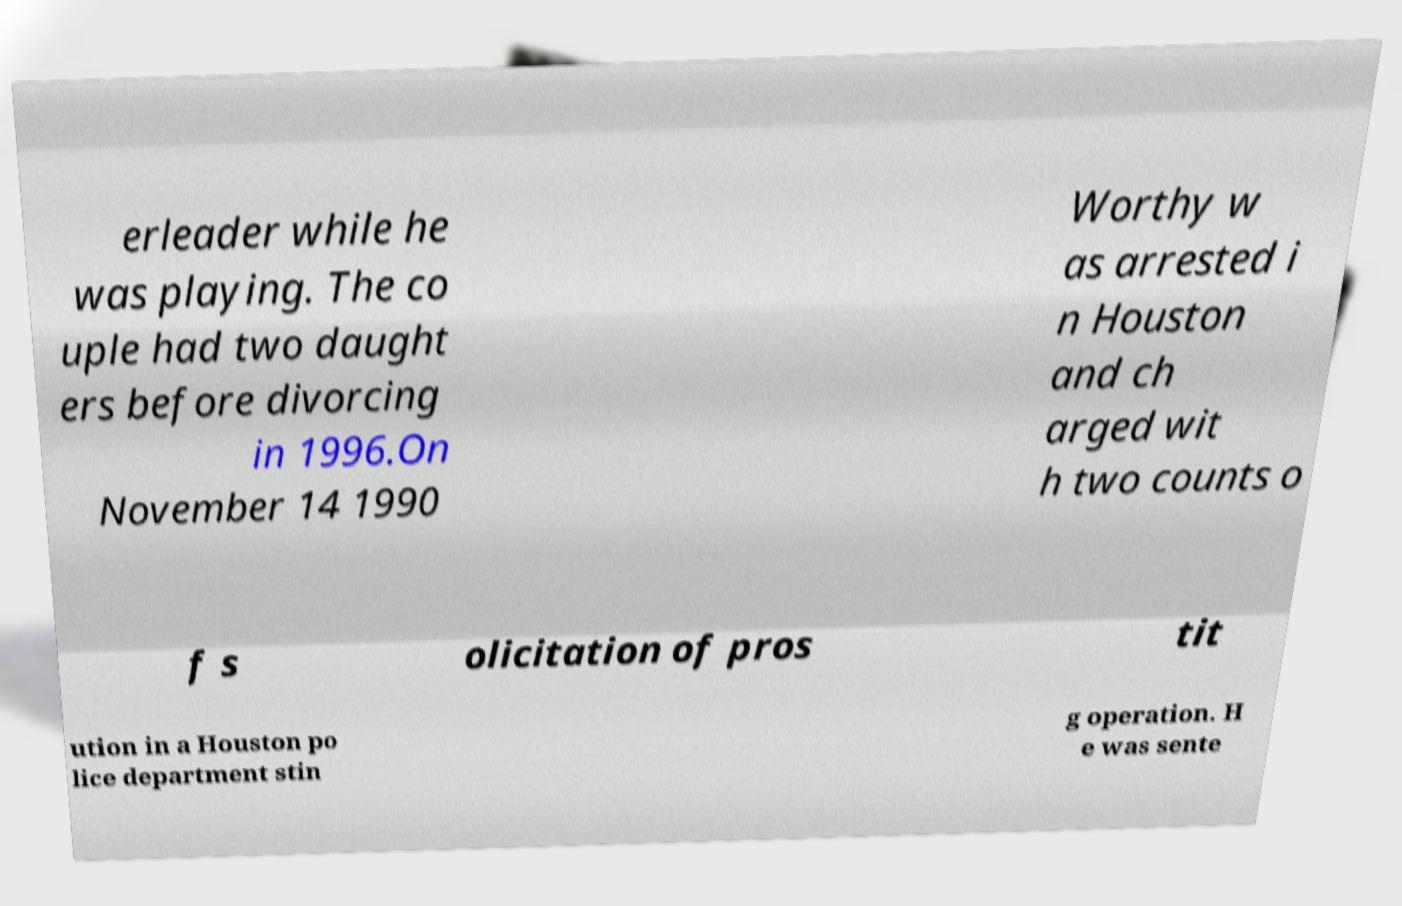Can you accurately transcribe the text from the provided image for me? erleader while he was playing. The co uple had two daught ers before divorcing in 1996.On November 14 1990 Worthy w as arrested i n Houston and ch arged wit h two counts o f s olicitation of pros tit ution in a Houston po lice department stin g operation. H e was sente 